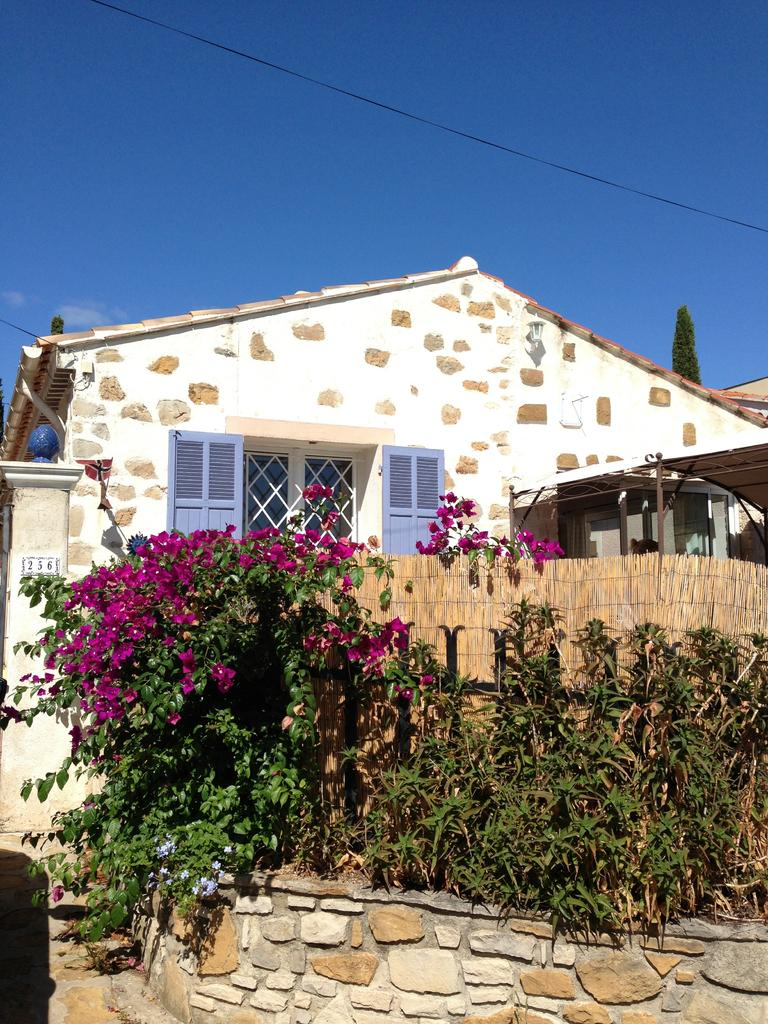What type of structure is present in the image? There is a house in the image. What can be seen in front of the house? There are plants and flowers in front of the house. What is located behind the house? There is a tree behind the house. What is visible in the background of the image? The sky is visible in the background of the image. What type of fiction is being read by the girl in the image? There is no girl present in the image. 